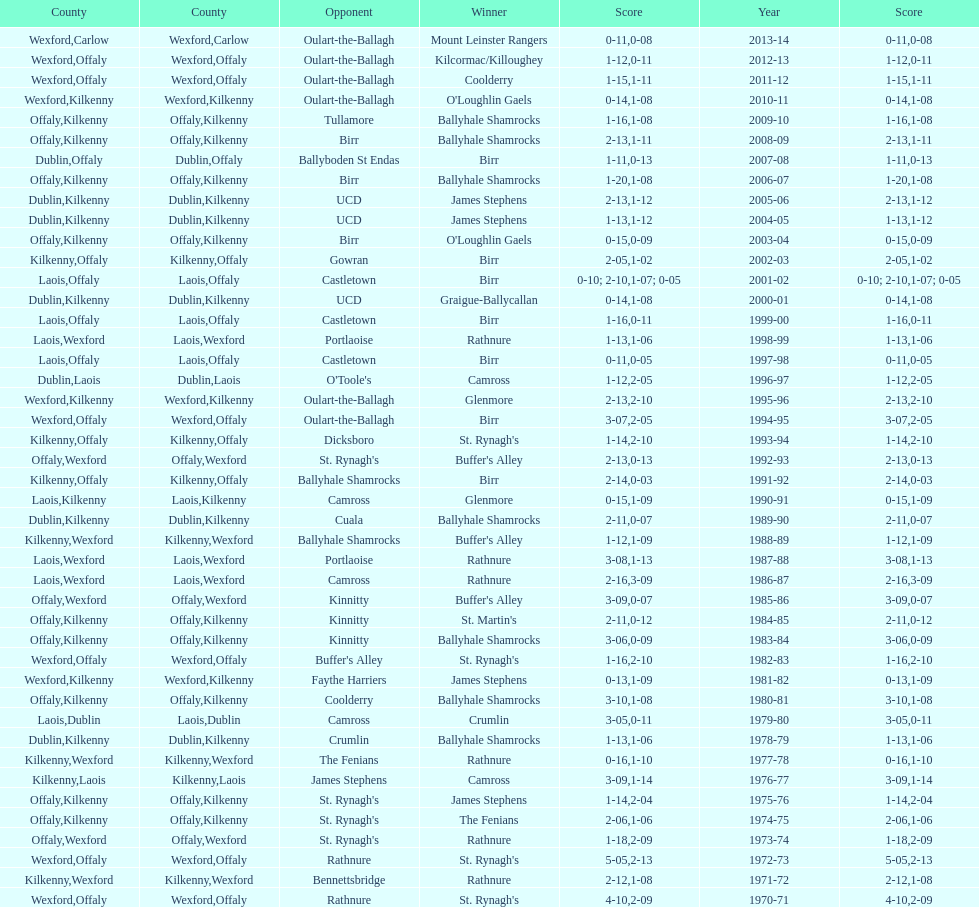Which team won the leinster senior club hurling championships previous to the last time birr won? Ballyhale Shamrocks. 